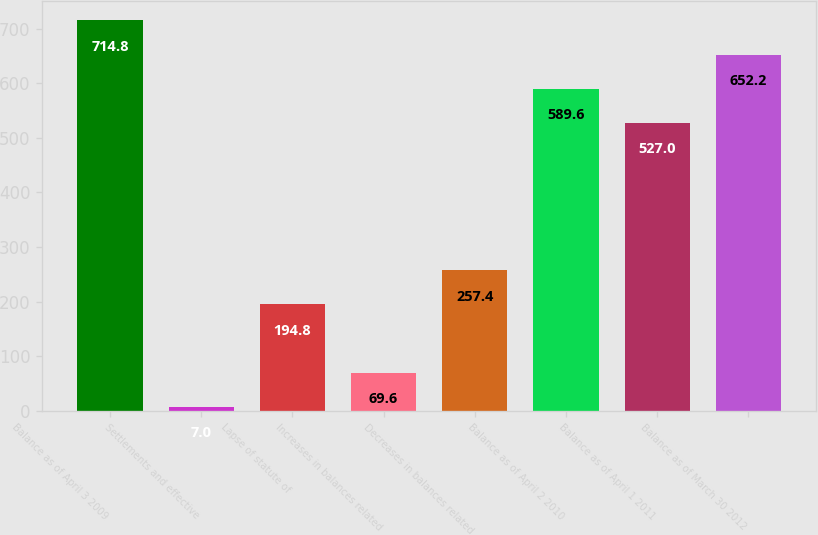Convert chart. <chart><loc_0><loc_0><loc_500><loc_500><bar_chart><fcel>Balance as of April 3 2009<fcel>Settlements and effective<fcel>Lapse of statute of<fcel>Increases in balances related<fcel>Decreases in balances related<fcel>Balance as of April 2 2010<fcel>Balance as of April 1 2011<fcel>Balance as of March 30 2012<nl><fcel>714.8<fcel>7<fcel>194.8<fcel>69.6<fcel>257.4<fcel>589.6<fcel>527<fcel>652.2<nl></chart> 